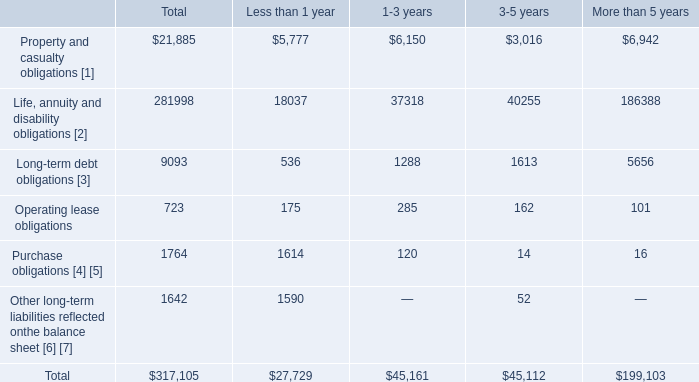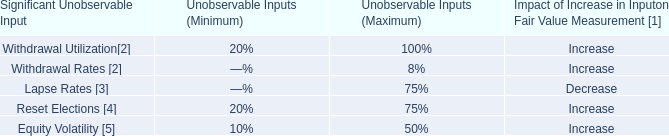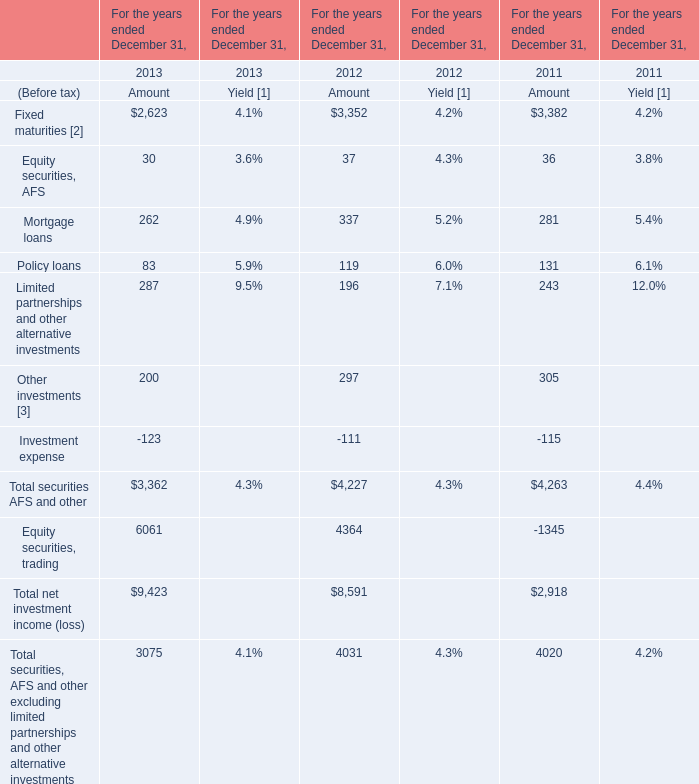what portion of total obligations are due within the next 3 years? 
Computations: ((27729 + 45161) / 317105)
Answer: 0.22986. 